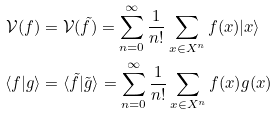Convert formula to latex. <formula><loc_0><loc_0><loc_500><loc_500>\mathcal { V } ( f ) & = \mathcal { V } ( \tilde { f } ) = \sum _ { n = 0 } ^ { \infty } \frac { 1 } { n ! } \sum _ { x \in X ^ { n } } f ( x ) | x \rangle \\ \langle f | g \rangle & = \langle \tilde { f } | \tilde { g } \rangle = \sum _ { n = 0 } ^ { \infty } \frac { 1 } { n ! } \sum _ { x \in X ^ { n } } f ( x ) g ( x )</formula> 